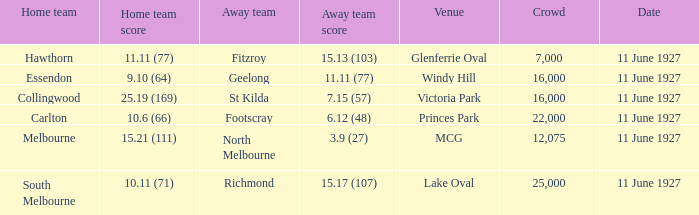Could you help me parse every detail presented in this table? {'header': ['Home team', 'Home team score', 'Away team', 'Away team score', 'Venue', 'Crowd', 'Date'], 'rows': [['Hawthorn', '11.11 (77)', 'Fitzroy', '15.13 (103)', 'Glenferrie Oval', '7,000', '11 June 1927'], ['Essendon', '9.10 (64)', 'Geelong', '11.11 (77)', 'Windy Hill', '16,000', '11 June 1927'], ['Collingwood', '25.19 (169)', 'St Kilda', '7.15 (57)', 'Victoria Park', '16,000', '11 June 1927'], ['Carlton', '10.6 (66)', 'Footscray', '6.12 (48)', 'Princes Park', '22,000', '11 June 1927'], ['Melbourne', '15.21 (111)', 'North Melbourne', '3.9 (27)', 'MCG', '12,075', '11 June 1927'], ['South Melbourne', '10.11 (71)', 'Richmond', '15.17 (107)', 'Lake Oval', '25,000', '11 June 1927']]} How many people were present in a total of every crowd at the MCG venue? 12075.0. 